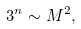<formula> <loc_0><loc_0><loc_500><loc_500>3 ^ { n } \sim M ^ { 2 } ,</formula> 